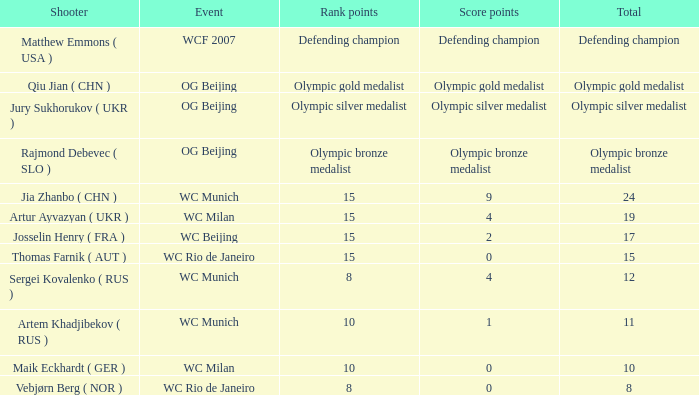With an overall of 11, what is the points score? 1.0. 